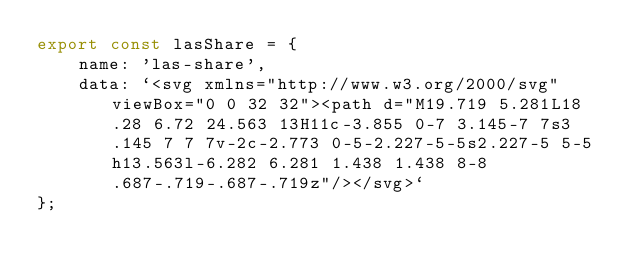Convert code to text. <code><loc_0><loc_0><loc_500><loc_500><_JavaScript_>export const lasShare = {
    name: 'las-share',
    data: `<svg xmlns="http://www.w3.org/2000/svg" viewBox="0 0 32 32"><path d="M19.719 5.281L18.28 6.72 24.563 13H11c-3.855 0-7 3.145-7 7s3.145 7 7 7v-2c-2.773 0-5-2.227-5-5s2.227-5 5-5h13.563l-6.282 6.281 1.438 1.438 8-8 .687-.719-.687-.719z"/></svg>`
};
</code> 